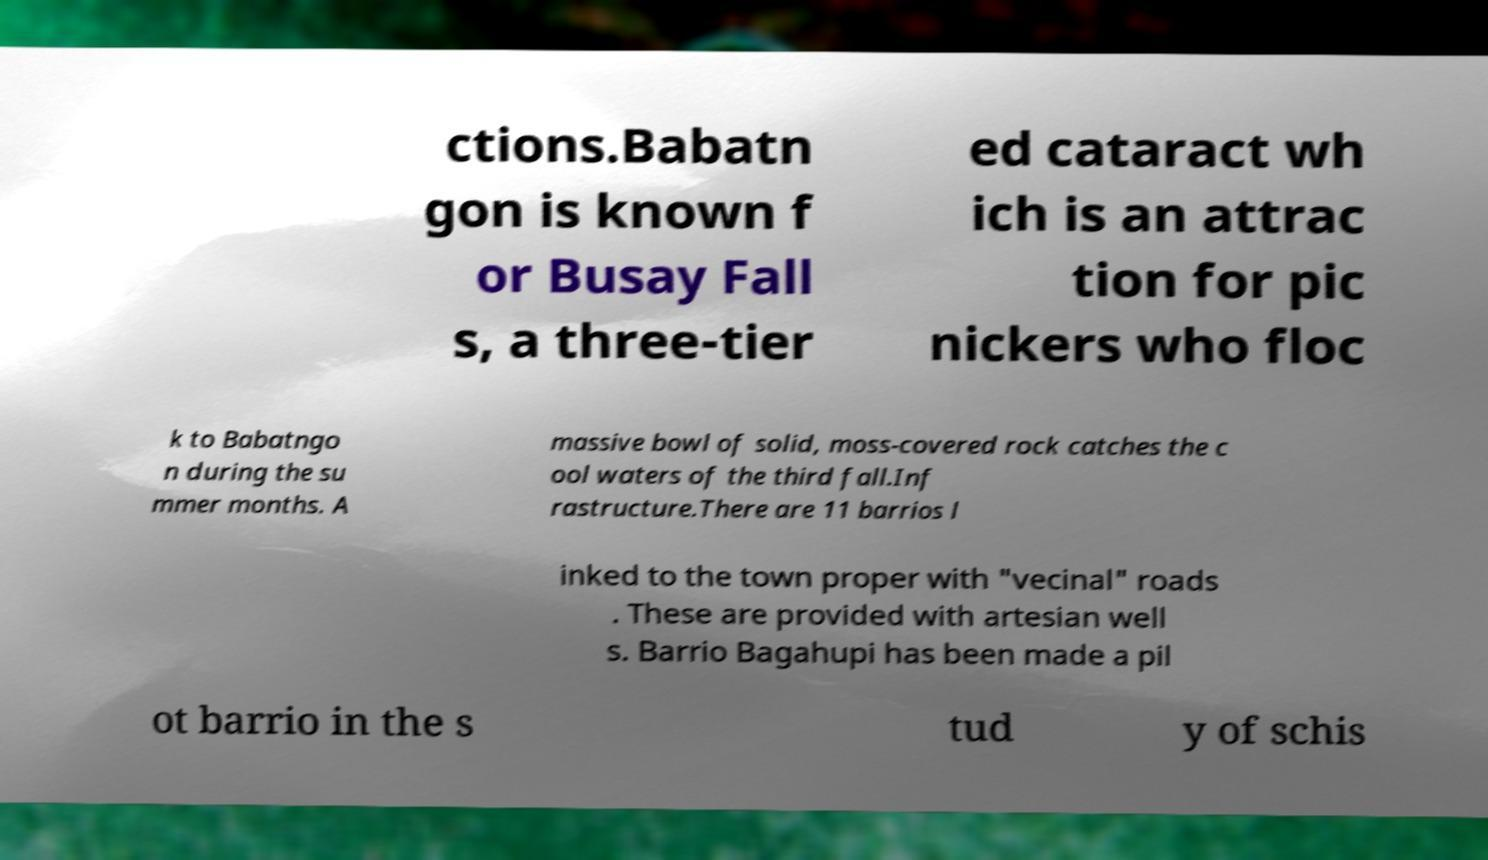What messages or text are displayed in this image? I need them in a readable, typed format. ctions.Babatn gon is known f or Busay Fall s, a three-tier ed cataract wh ich is an attrac tion for pic nickers who floc k to Babatngo n during the su mmer months. A massive bowl of solid, moss-covered rock catches the c ool waters of the third fall.Inf rastructure.There are 11 barrios l inked to the town proper with "vecinal" roads . These are provided with artesian well s. Barrio Bagahupi has been made a pil ot barrio in the s tud y of schis 